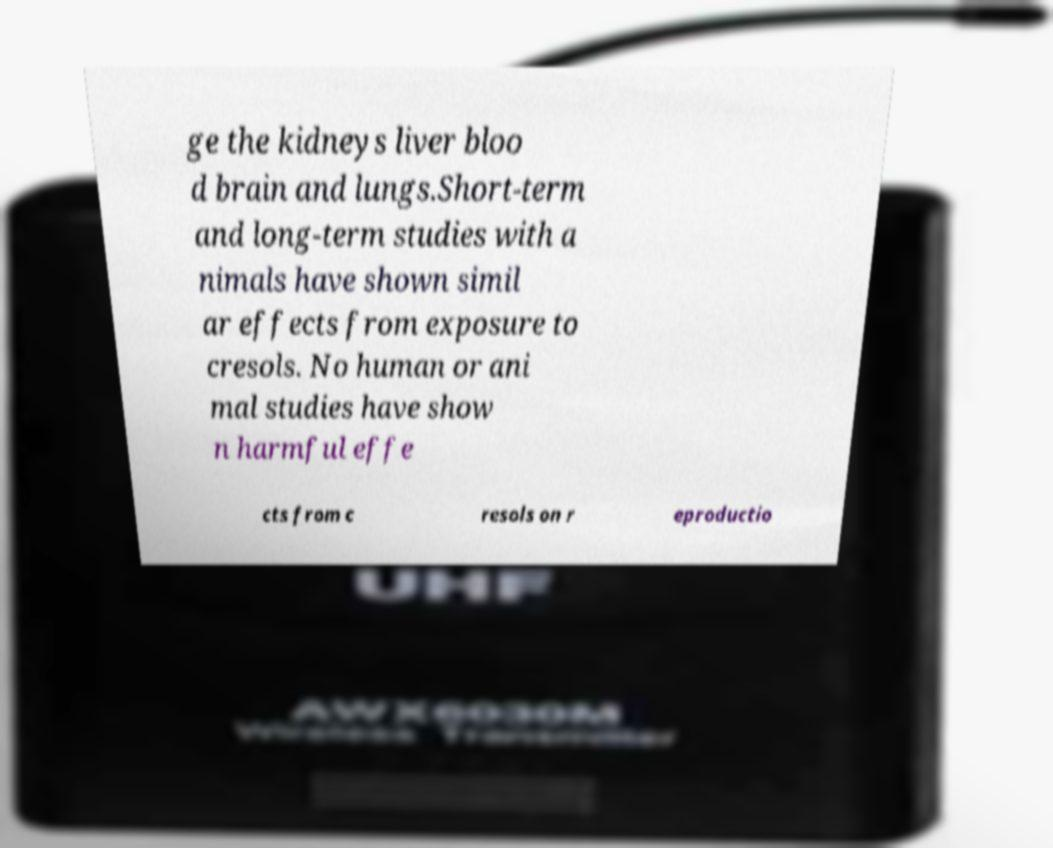Could you extract and type out the text from this image? ge the kidneys liver bloo d brain and lungs.Short-term and long-term studies with a nimals have shown simil ar effects from exposure to cresols. No human or ani mal studies have show n harmful effe cts from c resols on r eproductio 